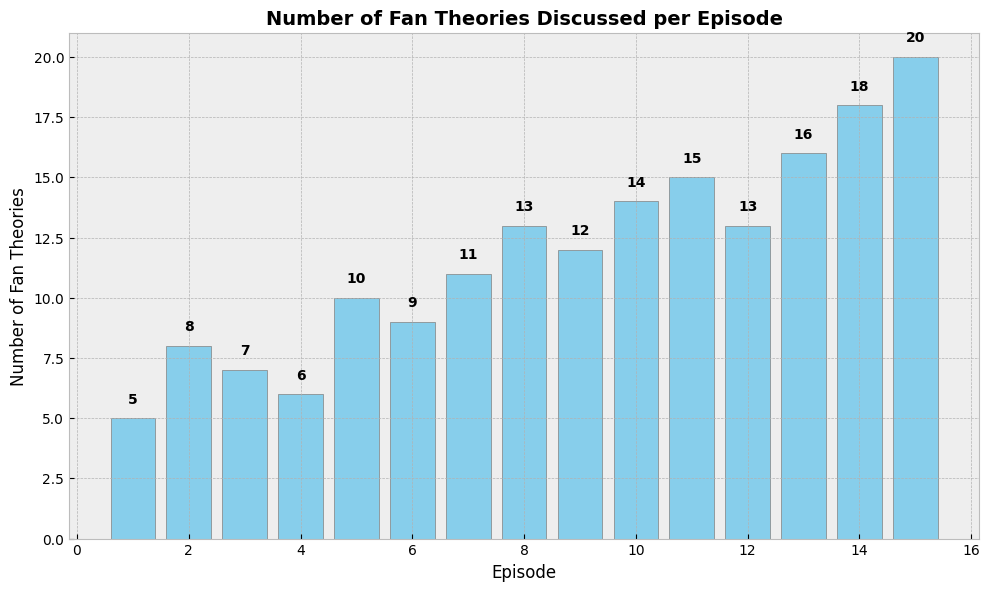How many fan theories were discussed across all episodes combined? First, sum the number of fan theories discussed for each episode: 5 + 8 + 7 + 6 + 10 + 9 + 11 + 13 + 12 + 14 + 15 + 13 + 16 + 18 + 20 = 177
Answer: 177 Which episode had the highest number of fan theories discussed? The bar for episode 15 is the tallest, indicating that it had the highest number of fan theories discussed.
Answer: Episode 15 What's the difference between the number of theories discussed in episode 15 and episode 1? Subtract the number of theories in episode 1 from episode 15: 20 - 5 = 15
Answer: 15 How many episodes had fan theories in double digits? Episodes 5, 6, 7, 8, 9, 10, 11, 12, 13, 14, and 15 have fan theories in double digits. Count these episodes: 11 episodes.
Answer: 11 What is the average number of fan theories discussed per episode? Sum the total fan theories (177) and divide by the number of episodes (15): 177 / 15 ≈ 11.8
Answer: 11.8 Which episodes had more than 13 fan theories discussed? Episodes 13, 14, and 15 all have more than 13 fan theories.
Answer: Episodes 13, 14, 15 Is there a general trend in the number of fan theories discussed per episode? The bars generally increase in height from left to right, indicating an overall increasing trend in the number of fan theories discussed as the episodes progress.
Answer: Increasing trend 